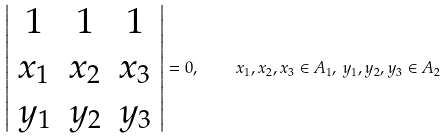<formula> <loc_0><loc_0><loc_500><loc_500>\left | \begin{array} { c c c } 1 & 1 & 1 \\ x _ { 1 } & x _ { 2 } & x _ { 3 } \\ y _ { 1 } & y _ { 2 } & y _ { 3 } \\ \end{array} \right | = 0 , \quad x _ { 1 } , x _ { 2 } , x _ { 3 } \in A _ { 1 } , \, y _ { 1 } , y _ { 2 } , y _ { 3 } \in A _ { 2 }</formula> 